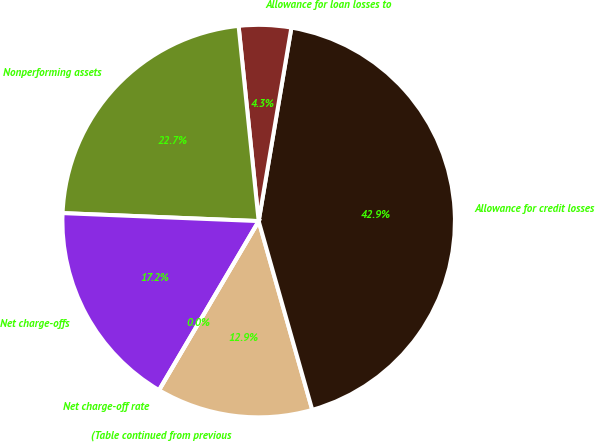Convert chart to OTSL. <chart><loc_0><loc_0><loc_500><loc_500><pie_chart><fcel>(Table continued from previous<fcel>Allowance for credit losses<fcel>Allowance for loan losses to<fcel>Nonperforming assets<fcel>Net charge-offs<fcel>Net charge-off rate<nl><fcel>12.88%<fcel>42.93%<fcel>4.3%<fcel>22.72%<fcel>17.17%<fcel>0.0%<nl></chart> 